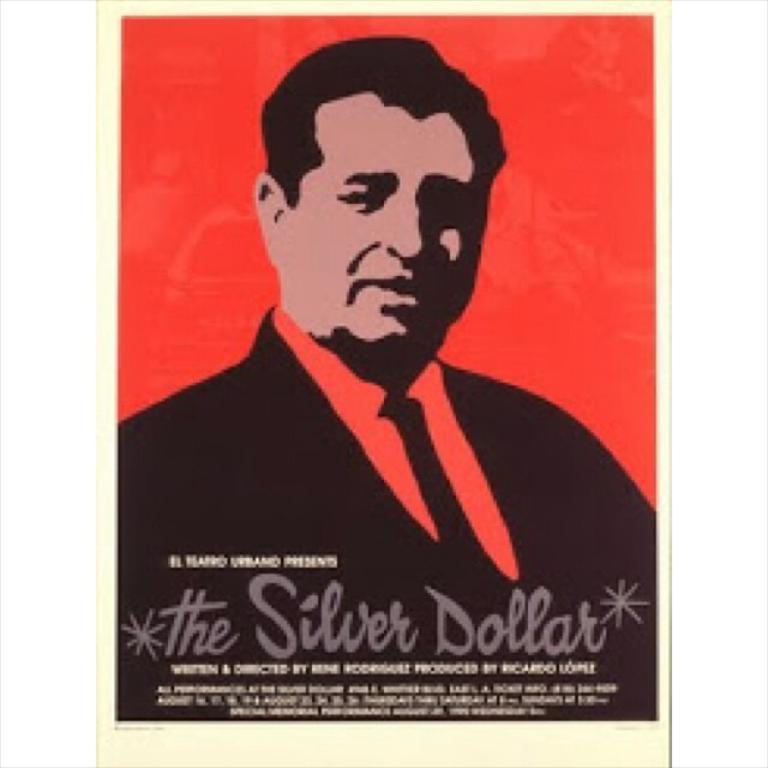Who or what is the main subject of the image? There is a person in the image. What else can be seen in the image besides the person? There is text written on something in the image. Can you describe the background color of the image? The background color is a combination of red and cream. What is the relation between the person and the text in the image? There is no information about the relation between the person and the text in the image. 